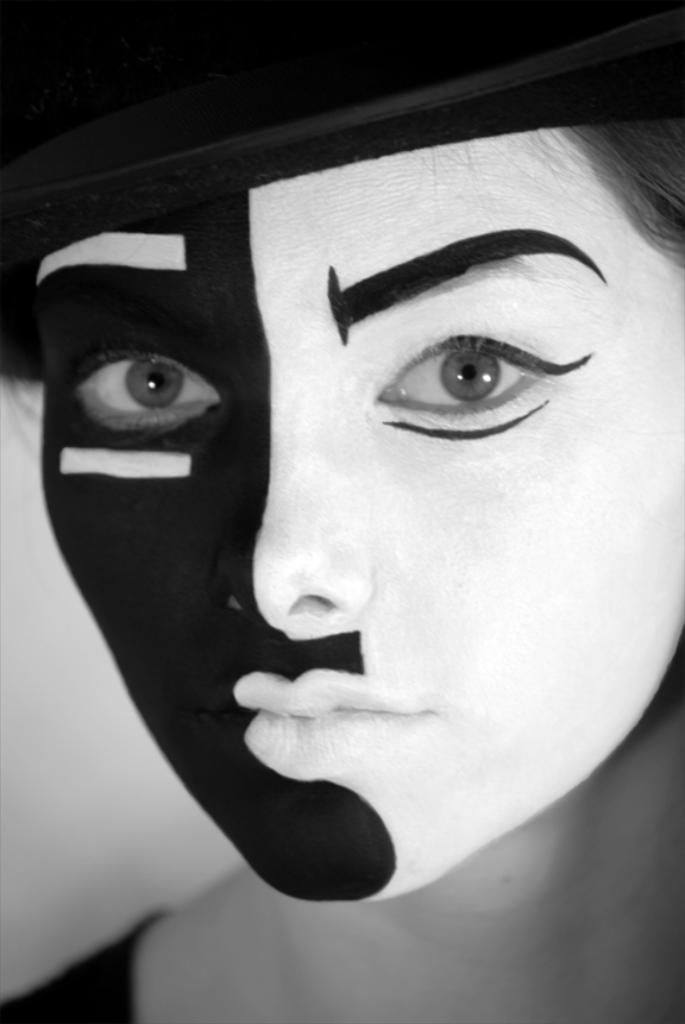How would you summarize this image in a sentence or two? This is a black and white image and here we can see a person wearing a mask and a cap. 